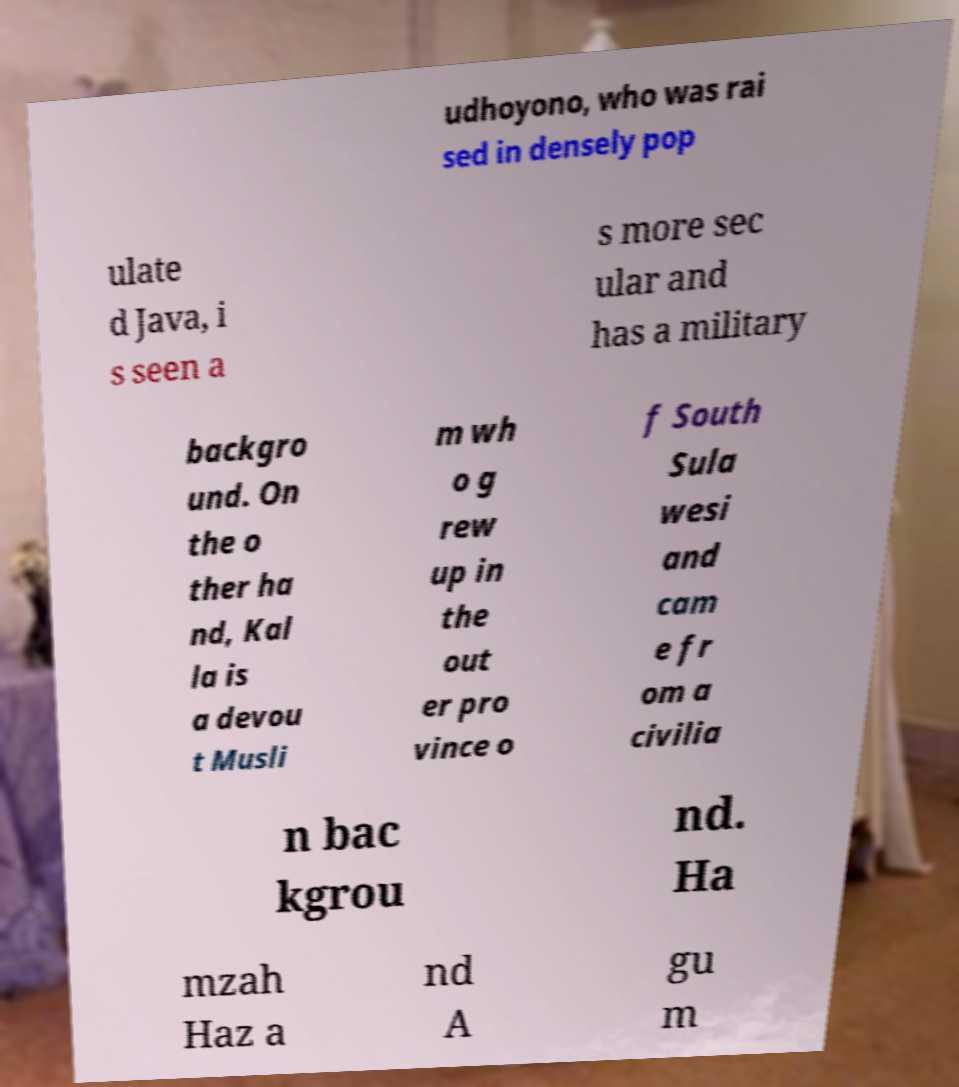For documentation purposes, I need the text within this image transcribed. Could you provide that? udhoyono, who was rai sed in densely pop ulate d Java, i s seen a s more sec ular and has a military backgro und. On the o ther ha nd, Kal la is a devou t Musli m wh o g rew up in the out er pro vince o f South Sula wesi and cam e fr om a civilia n bac kgrou nd. Ha mzah Haz a nd A gu m 